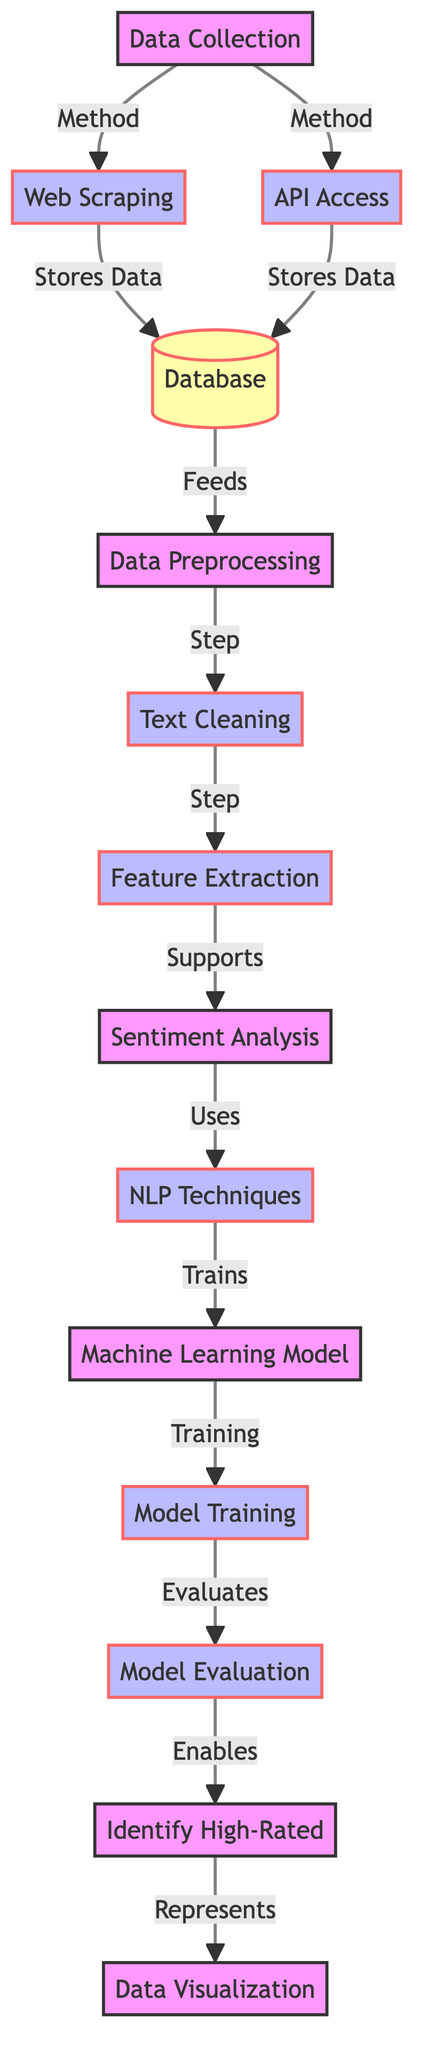what are the two methods for data collection? The diagram lists two methods for data collection: web scraping and API access. Both are represented as arrows leading away from the data collection node.
Answer: web scraping and API access which step follows data preprocessing in the diagram? In the flow of the diagram, the step that follows data preprocessing is text cleaning. It is the next node connected to data preprocessing.
Answer: text cleaning how many processes are involved in total within the diagram? To find the total number of processes, we can count the nodes that represent processes, which are web scraping, API access, text cleaning, feature extraction, NLP techniques, model training, and model evaluation. This totals to seven processes.
Answer: seven what does the sentiment analysis node support? The sentiment analysis node directly supports the feature extraction node, as indicated by the arrow connecting the two nodes in the diagram.
Answer: feature extraction which section of the diagram contains the output visualization? The visualization of data is represented in the identification high-rated node, which is where the outcome of the entire analysis is visually represented.
Answer: identification high-rated which node indicates the use of NLP techniques? The NLP techniques are indicated as part of the sentiment analysis node in the diagram, showing the relationship where sentiment analysis uses these techniques.
Answer: sentiment analysis what is the relationship between model evaluation and identification high-rated? The model evaluation node enables the identification of high-rated bourbons, as indicated by the arrow that connects these two nodes.
Answer: enables how does data get stored in the database? Data gets stored in the database through the processes of web scraping and API access, as indicated by both methods having arrows directed toward the database node.
Answer: web scraping and API access 